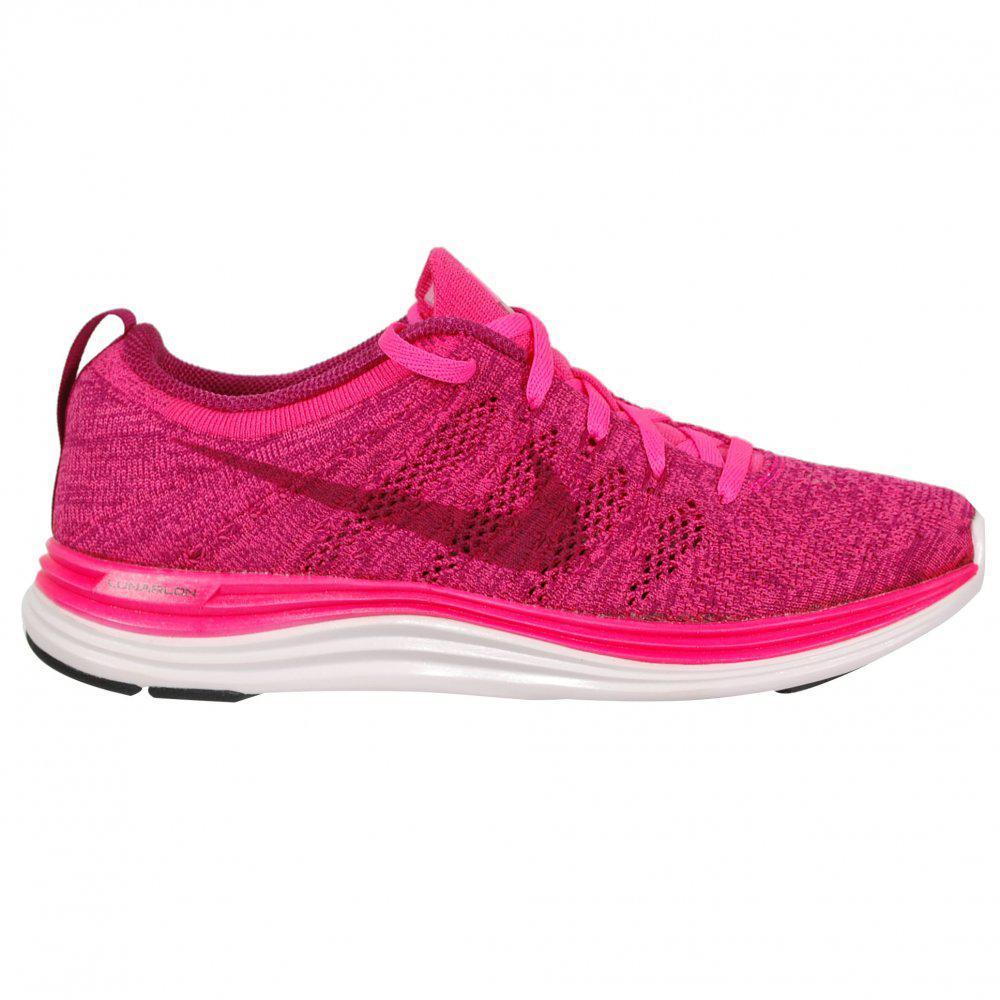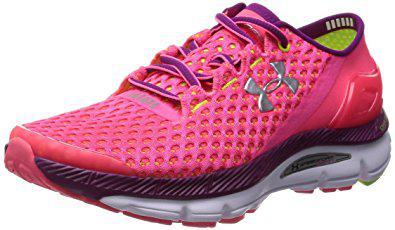The first image is the image on the left, the second image is the image on the right. For the images displayed, is the sentence "The matching pair of shoes faces left." factually correct? Answer yes or no. No. The first image is the image on the left, the second image is the image on the right. For the images shown, is this caption "There are three total shoes in the pair." true? Answer yes or no. No. 